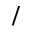Convert formula to latex. <formula><loc_0><loc_0><loc_500><loc_500>/</formula> 